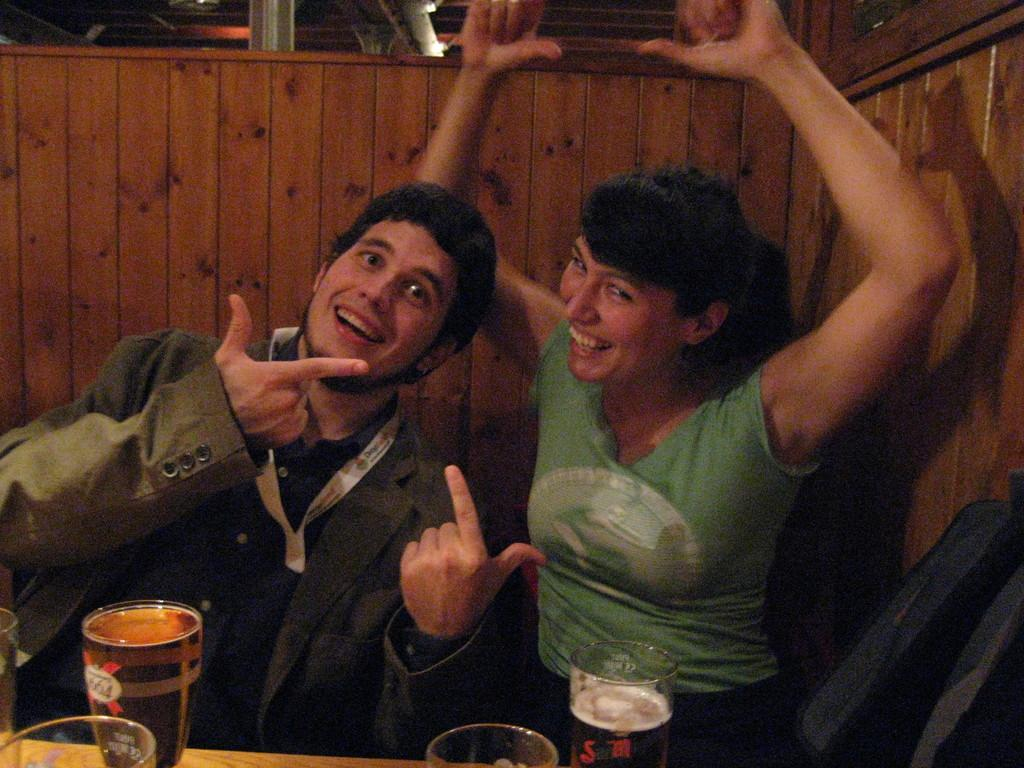How many people are present in the image? There are two people, a man and a woman, present in the image. What are the expressions of the people in the image? Both the man and woman are smiling in the image. What objects can be seen on the table in the image? There are glasses and a tin can on the table in the image. What type of wall is visible in the background? There is a wooden wall in the background of the image. What other objects can be seen in the background? There are other objects visible in the background, but their specific details are not mentioned in the provided facts. How many books are stacked on the ship in the image? There is no ship or books present in the image. 